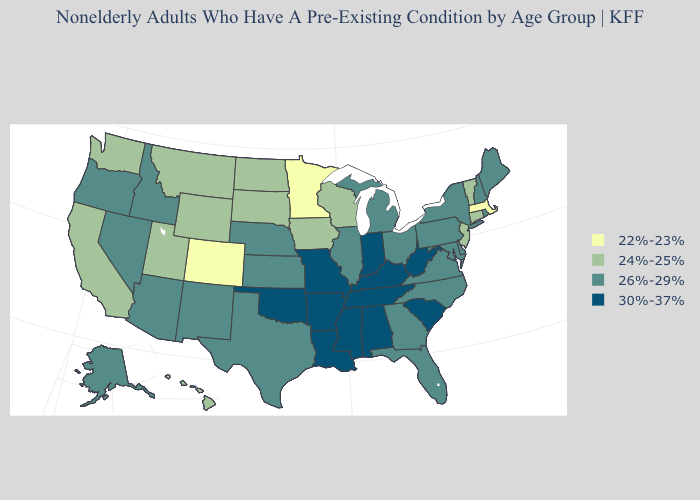What is the value of New Mexico?
Write a very short answer. 26%-29%. Name the states that have a value in the range 26%-29%?
Keep it brief. Alaska, Arizona, Delaware, Florida, Georgia, Idaho, Illinois, Kansas, Maine, Maryland, Michigan, Nebraska, Nevada, New Hampshire, New Mexico, New York, North Carolina, Ohio, Oregon, Pennsylvania, Rhode Island, Texas, Virginia. Does California have the highest value in the West?
Keep it brief. No. Among the states that border Virginia , does North Carolina have the lowest value?
Write a very short answer. Yes. What is the value of Tennessee?
Concise answer only. 30%-37%. Which states have the lowest value in the MidWest?
Answer briefly. Minnesota. Name the states that have a value in the range 24%-25%?
Keep it brief. California, Connecticut, Hawaii, Iowa, Montana, New Jersey, North Dakota, South Dakota, Utah, Vermont, Washington, Wisconsin, Wyoming. Does Kentucky have a lower value than Missouri?
Short answer required. No. What is the highest value in the USA?
Give a very brief answer. 30%-37%. What is the highest value in the USA?
Answer briefly. 30%-37%. What is the highest value in states that border Florida?
Concise answer only. 30%-37%. How many symbols are there in the legend?
Concise answer only. 4. Which states have the highest value in the USA?
Give a very brief answer. Alabama, Arkansas, Indiana, Kentucky, Louisiana, Mississippi, Missouri, Oklahoma, South Carolina, Tennessee, West Virginia. Does North Dakota have a higher value than Colorado?
Short answer required. Yes. Which states have the lowest value in the USA?
Answer briefly. Colorado, Massachusetts, Minnesota. 